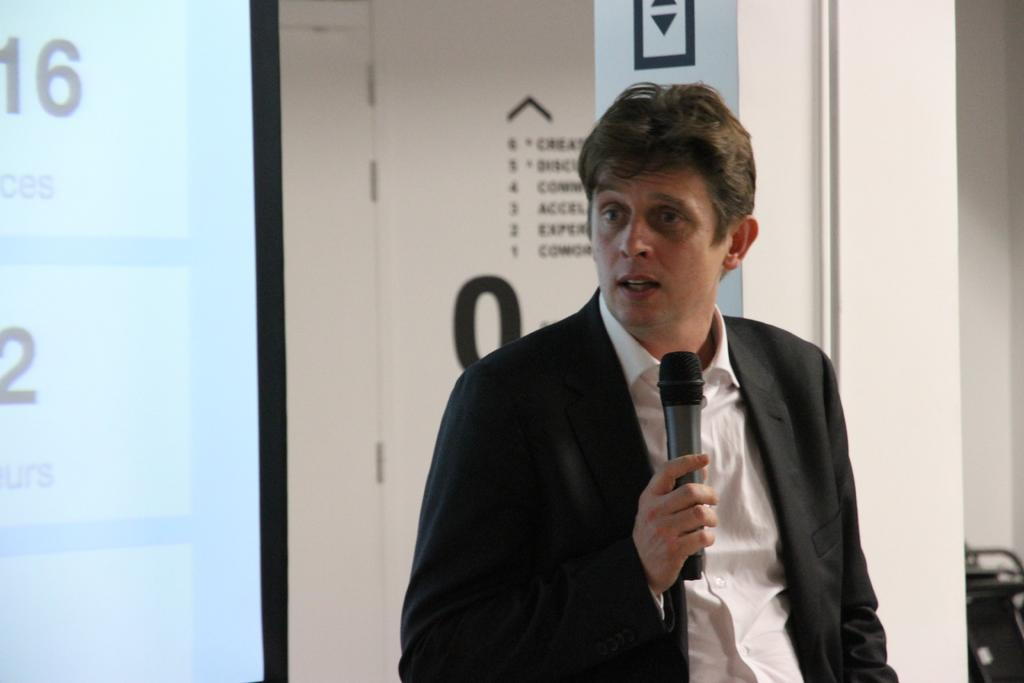Who is present in the image? There is a guy in the image. What is the guy wearing? The guy is wearing a black coat. What is the guy holding in his hand? The guy is holding something in his hand. What can be seen in the background of the image? There is a glass window in the background of the image. How many friends is the guy standing on in the image? There is no indication in the image that the guy is standing on any friends. 